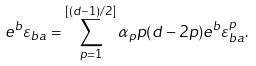Convert formula to latex. <formula><loc_0><loc_0><loc_500><loc_500>e ^ { b } \varepsilon _ { b a } = \sum _ { p = 1 } ^ { \left [ \left ( d - 1 \right ) / 2 \right ] } \alpha _ { p } p ( d - 2 p ) e ^ { b } \varepsilon _ { b a } ^ { p } .</formula> 